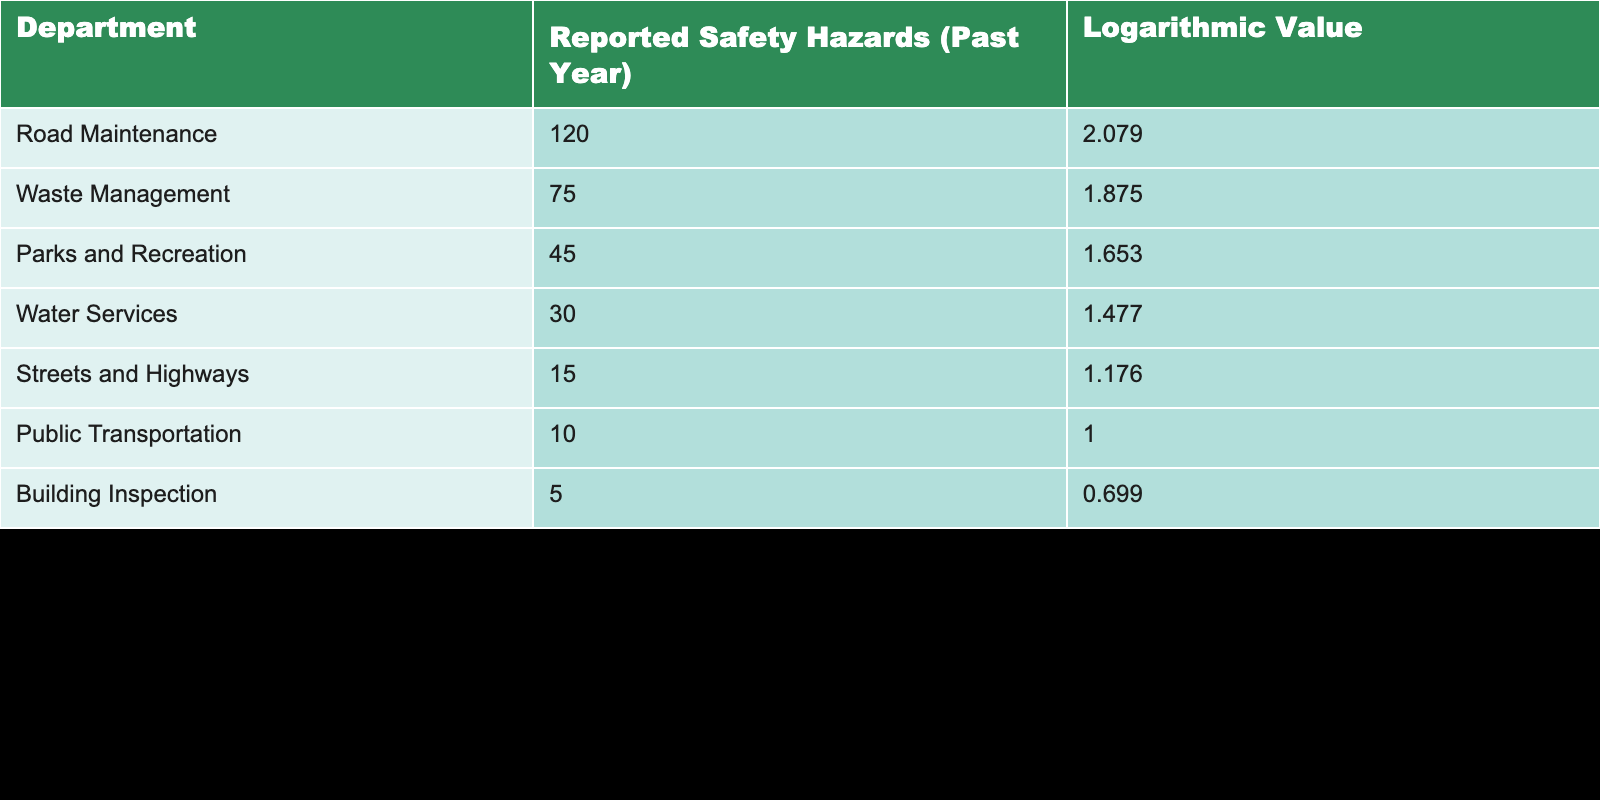What department reported the highest number of safety hazards? The table shows that the Road Maintenance department reported 120 safety hazards, which is the highest among all departments listed.
Answer: Road Maintenance What is the logarithmic value for Waste Management? According to the table, the logarithmic value for Waste Management is 1.875, as listed under the Logarithmic Value column.
Answer: 1.875 Which department has the lowest number of reported safety hazards, and what is that number? The Building Inspection department has the lowest reported safety hazards at 5, as indicated in the table.
Answer: Building Inspection, 5 What is the total number of reported safety hazards for Parks and Recreation and Water Services combined? To find the total, we add the reported safety hazards for Parks and Recreation (45) and Water Services (30): 45 + 30 = 75.
Answer: 75 Is it true that Public Transportation reported more safety hazards than Streets and Highways? By comparing the reported safety hazards, Public Transportation has 10 while Streets and Highways has 15. Since 10 is less than 15, the statement is false.
Answer: No What is the average number of reported safety hazards across all departments? To find the average, we sum the reported hazards: 120 + 75 + 45 + 30 + 15 + 10 + 5 = 300. Then, divide by the number of departments (7): 300/7 ≈ 42.86.
Answer: 42.86 Which department has a logarithmic value lower than 1.5? The departments with logarithmic values lower than 1.5 are Water Services (1.477), Streets and Highways (1.176), Public Transportation (1.000), and Building Inspection (0.699).
Answer: Water Services, Streets and Highways, Public Transportation, Building Inspection How many more reported safety hazards did Road Maintenance have compared to Building Inspection? The difference in reported safety hazards between Road Maintenance (120) and Building Inspection (5) is calculated as 120 - 5 = 115.
Answer: 115 